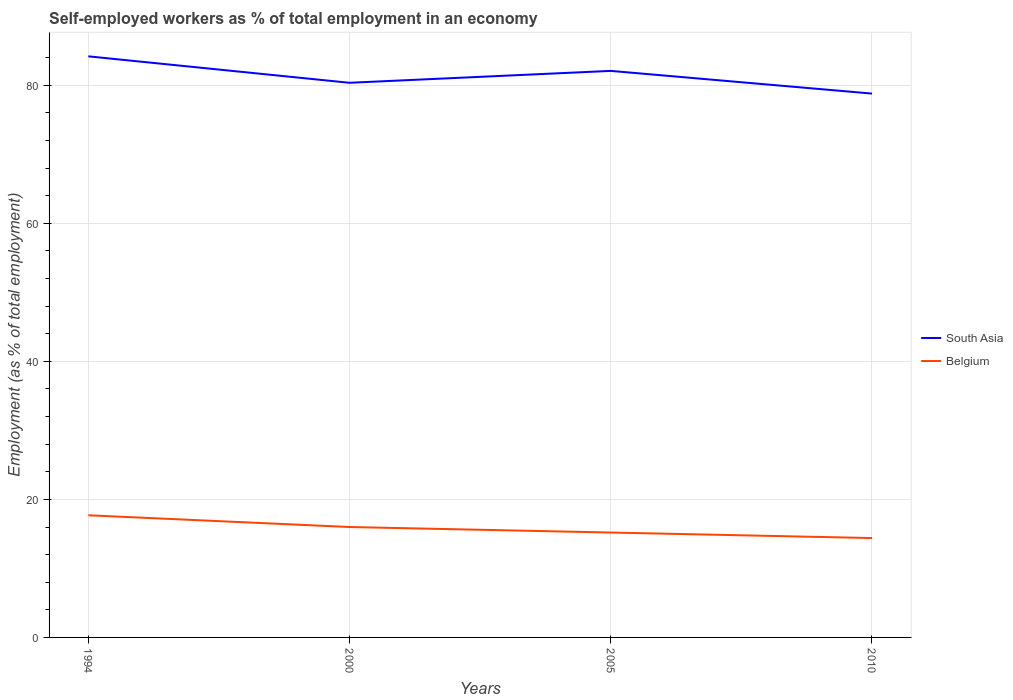Does the line corresponding to Belgium intersect with the line corresponding to South Asia?
Make the answer very short. No. Across all years, what is the maximum percentage of self-employed workers in South Asia?
Provide a short and direct response. 78.81. In which year was the percentage of self-employed workers in Belgium maximum?
Provide a short and direct response. 2010. What is the total percentage of self-employed workers in South Asia in the graph?
Keep it short and to the point. 3.29. What is the difference between the highest and the second highest percentage of self-employed workers in South Asia?
Your response must be concise. 5.4. Is the percentage of self-employed workers in South Asia strictly greater than the percentage of self-employed workers in Belgium over the years?
Make the answer very short. No. How many lines are there?
Your answer should be very brief. 2. How many years are there in the graph?
Ensure brevity in your answer.  4. What is the difference between two consecutive major ticks on the Y-axis?
Offer a terse response. 20. Are the values on the major ticks of Y-axis written in scientific E-notation?
Your answer should be very brief. No. Does the graph contain grids?
Offer a very short reply. Yes. Where does the legend appear in the graph?
Give a very brief answer. Center right. How many legend labels are there?
Your response must be concise. 2. What is the title of the graph?
Your response must be concise. Self-employed workers as % of total employment in an economy. Does "Paraguay" appear as one of the legend labels in the graph?
Ensure brevity in your answer.  No. What is the label or title of the X-axis?
Give a very brief answer. Years. What is the label or title of the Y-axis?
Keep it short and to the point. Employment (as % of total employment). What is the Employment (as % of total employment) of South Asia in 1994?
Ensure brevity in your answer.  84.21. What is the Employment (as % of total employment) in Belgium in 1994?
Keep it short and to the point. 17.7. What is the Employment (as % of total employment) in South Asia in 2000?
Provide a succinct answer. 80.37. What is the Employment (as % of total employment) of South Asia in 2005?
Offer a very short reply. 82.1. What is the Employment (as % of total employment) of Belgium in 2005?
Provide a short and direct response. 15.2. What is the Employment (as % of total employment) of South Asia in 2010?
Provide a short and direct response. 78.81. What is the Employment (as % of total employment) in Belgium in 2010?
Provide a succinct answer. 14.4. Across all years, what is the maximum Employment (as % of total employment) in South Asia?
Offer a terse response. 84.21. Across all years, what is the maximum Employment (as % of total employment) of Belgium?
Your answer should be compact. 17.7. Across all years, what is the minimum Employment (as % of total employment) in South Asia?
Keep it short and to the point. 78.81. Across all years, what is the minimum Employment (as % of total employment) of Belgium?
Offer a terse response. 14.4. What is the total Employment (as % of total employment) of South Asia in the graph?
Offer a very short reply. 325.48. What is the total Employment (as % of total employment) in Belgium in the graph?
Offer a very short reply. 63.3. What is the difference between the Employment (as % of total employment) of South Asia in 1994 and that in 2000?
Your response must be concise. 3.83. What is the difference between the Employment (as % of total employment) in South Asia in 1994 and that in 2005?
Your answer should be very brief. 2.11. What is the difference between the Employment (as % of total employment) of South Asia in 1994 and that in 2010?
Give a very brief answer. 5.4. What is the difference between the Employment (as % of total employment) of Belgium in 1994 and that in 2010?
Provide a succinct answer. 3.3. What is the difference between the Employment (as % of total employment) in South Asia in 2000 and that in 2005?
Make the answer very short. -1.72. What is the difference between the Employment (as % of total employment) in Belgium in 2000 and that in 2005?
Give a very brief answer. 0.8. What is the difference between the Employment (as % of total employment) of South Asia in 2000 and that in 2010?
Provide a short and direct response. 1.57. What is the difference between the Employment (as % of total employment) in Belgium in 2000 and that in 2010?
Your response must be concise. 1.6. What is the difference between the Employment (as % of total employment) in South Asia in 2005 and that in 2010?
Provide a short and direct response. 3.29. What is the difference between the Employment (as % of total employment) in South Asia in 1994 and the Employment (as % of total employment) in Belgium in 2000?
Your answer should be compact. 68.21. What is the difference between the Employment (as % of total employment) of South Asia in 1994 and the Employment (as % of total employment) of Belgium in 2005?
Your answer should be very brief. 69.01. What is the difference between the Employment (as % of total employment) of South Asia in 1994 and the Employment (as % of total employment) of Belgium in 2010?
Provide a succinct answer. 69.81. What is the difference between the Employment (as % of total employment) in South Asia in 2000 and the Employment (as % of total employment) in Belgium in 2005?
Your answer should be very brief. 65.17. What is the difference between the Employment (as % of total employment) of South Asia in 2000 and the Employment (as % of total employment) of Belgium in 2010?
Make the answer very short. 65.97. What is the difference between the Employment (as % of total employment) of South Asia in 2005 and the Employment (as % of total employment) of Belgium in 2010?
Your answer should be very brief. 67.7. What is the average Employment (as % of total employment) of South Asia per year?
Keep it short and to the point. 81.37. What is the average Employment (as % of total employment) in Belgium per year?
Offer a very short reply. 15.82. In the year 1994, what is the difference between the Employment (as % of total employment) of South Asia and Employment (as % of total employment) of Belgium?
Give a very brief answer. 66.51. In the year 2000, what is the difference between the Employment (as % of total employment) in South Asia and Employment (as % of total employment) in Belgium?
Your answer should be very brief. 64.37. In the year 2005, what is the difference between the Employment (as % of total employment) of South Asia and Employment (as % of total employment) of Belgium?
Your response must be concise. 66.9. In the year 2010, what is the difference between the Employment (as % of total employment) of South Asia and Employment (as % of total employment) of Belgium?
Your answer should be compact. 64.41. What is the ratio of the Employment (as % of total employment) in South Asia in 1994 to that in 2000?
Make the answer very short. 1.05. What is the ratio of the Employment (as % of total employment) of Belgium in 1994 to that in 2000?
Keep it short and to the point. 1.11. What is the ratio of the Employment (as % of total employment) in South Asia in 1994 to that in 2005?
Provide a succinct answer. 1.03. What is the ratio of the Employment (as % of total employment) of Belgium in 1994 to that in 2005?
Your answer should be compact. 1.16. What is the ratio of the Employment (as % of total employment) of South Asia in 1994 to that in 2010?
Offer a very short reply. 1.07. What is the ratio of the Employment (as % of total employment) of Belgium in 1994 to that in 2010?
Offer a terse response. 1.23. What is the ratio of the Employment (as % of total employment) of South Asia in 2000 to that in 2005?
Keep it short and to the point. 0.98. What is the ratio of the Employment (as % of total employment) in Belgium in 2000 to that in 2005?
Provide a succinct answer. 1.05. What is the ratio of the Employment (as % of total employment) of South Asia in 2000 to that in 2010?
Provide a short and direct response. 1.02. What is the ratio of the Employment (as % of total employment) of South Asia in 2005 to that in 2010?
Provide a short and direct response. 1.04. What is the ratio of the Employment (as % of total employment) of Belgium in 2005 to that in 2010?
Give a very brief answer. 1.06. What is the difference between the highest and the second highest Employment (as % of total employment) in South Asia?
Your answer should be compact. 2.11. What is the difference between the highest and the second highest Employment (as % of total employment) of Belgium?
Make the answer very short. 1.7. What is the difference between the highest and the lowest Employment (as % of total employment) in South Asia?
Provide a succinct answer. 5.4. What is the difference between the highest and the lowest Employment (as % of total employment) in Belgium?
Offer a terse response. 3.3. 